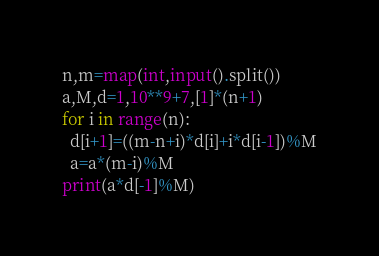<code> <loc_0><loc_0><loc_500><loc_500><_Python_>n,m=map(int,input().split())
a,M,d=1,10**9+7,[1]*(n+1)
for i in range(n):
  d[i+1]=((m-n+i)*d[i]+i*d[i-1])%M
  a=a*(m-i)%M
print(a*d[-1]%M)
</code> 